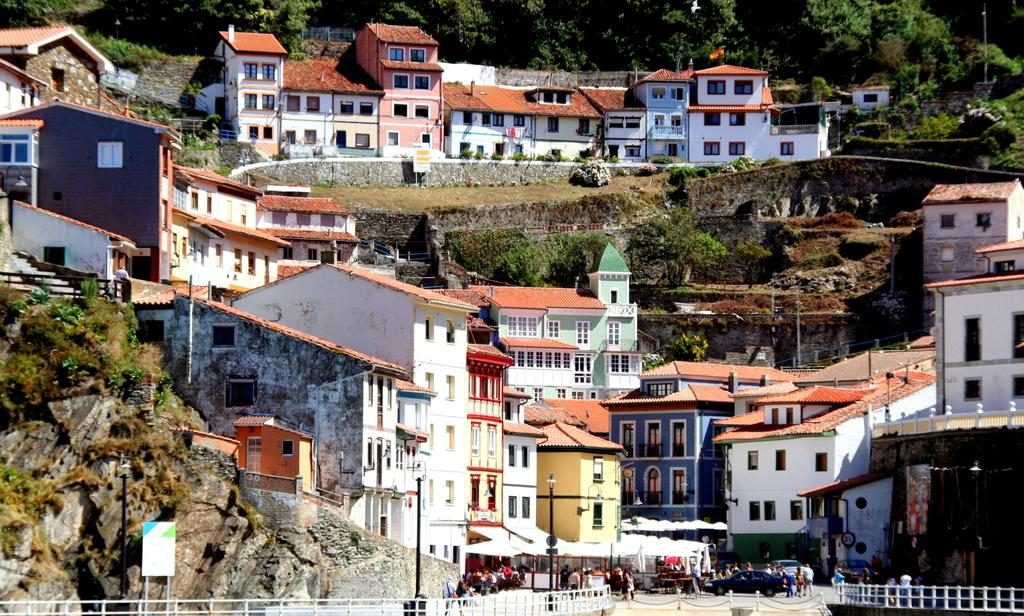What is present in the image that separates or encloses an area? There is a fence in the image. What are the people in the image doing near the fence? People are standing near the fence. What can be seen in the background of the image? There are buildings on a mountain in the background, and there are many trees visible on the mountain. Where is the cellar located in the image? There is no cellar present in the image. What type of mountain is visible in the image? The provided facts do not specify the type of mountain; it is simply described as having buildings and trees on it. 